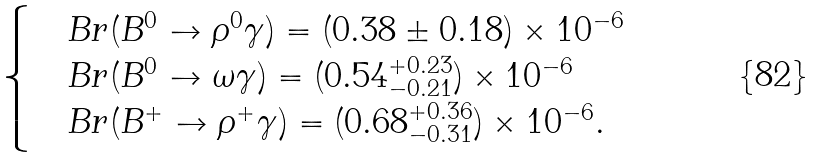<formula> <loc_0><loc_0><loc_500><loc_500>\begin{cases} & B r ( B ^ { 0 } \to \rho ^ { 0 } \gamma ) = ( 0 . 3 8 \pm 0 . 1 8 ) \times 1 0 ^ { - 6 } \\ & B r ( B ^ { 0 } \to \omega \gamma ) = ( 0 . 5 4 ^ { + 0 . 2 3 } _ { - 0 . 2 1 } ) \times 1 0 ^ { - 6 } \\ & B r ( B ^ { + } \to \rho ^ { + } \gamma ) = ( 0 . 6 8 ^ { + 0 . 3 6 } _ { - 0 . 3 1 } ) \times 1 0 ^ { - 6 } . \end{cases}</formula> 